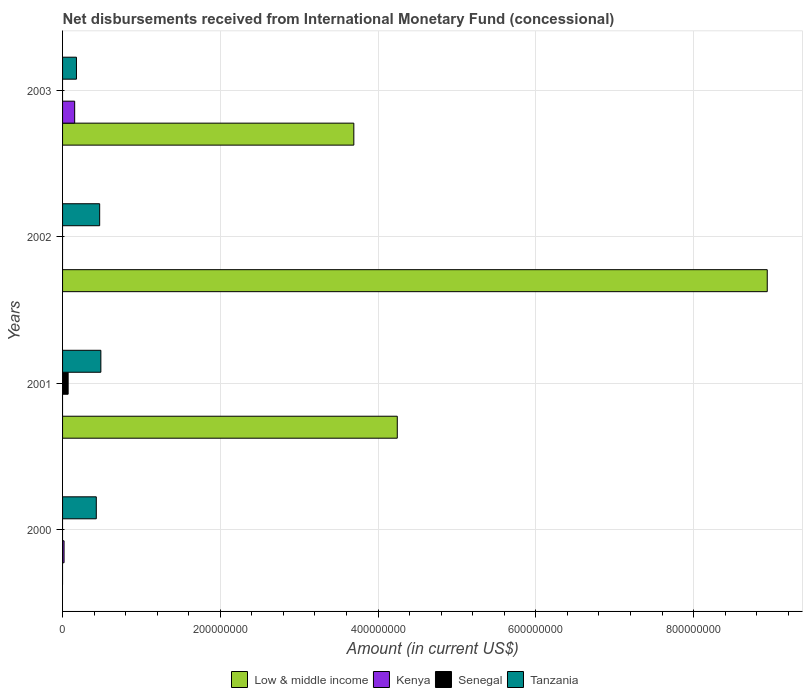How many different coloured bars are there?
Ensure brevity in your answer.  4. Are the number of bars per tick equal to the number of legend labels?
Give a very brief answer. No. How many bars are there on the 1st tick from the top?
Make the answer very short. 3. How many bars are there on the 1st tick from the bottom?
Provide a short and direct response. 2. What is the label of the 3rd group of bars from the top?
Keep it short and to the point. 2001. In how many cases, is the number of bars for a given year not equal to the number of legend labels?
Your answer should be compact. 4. Across all years, what is the maximum amount of disbursements received from International Monetary Fund in Senegal?
Your answer should be compact. 7.07e+06. What is the total amount of disbursements received from International Monetary Fund in Kenya in the graph?
Your answer should be very brief. 1.72e+07. What is the difference between the amount of disbursements received from International Monetary Fund in Tanzania in 2000 and that in 2003?
Provide a succinct answer. 2.52e+07. What is the difference between the amount of disbursements received from International Monetary Fund in Tanzania in 2000 and the amount of disbursements received from International Monetary Fund in Kenya in 2003?
Your answer should be compact. 2.74e+07. What is the average amount of disbursements received from International Monetary Fund in Kenya per year?
Your response must be concise. 4.31e+06. In the year 2001, what is the difference between the amount of disbursements received from International Monetary Fund in Tanzania and amount of disbursements received from International Monetary Fund in Low & middle income?
Make the answer very short. -3.76e+08. What is the ratio of the amount of disbursements received from International Monetary Fund in Tanzania in 2000 to that in 2002?
Your response must be concise. 0.91. What is the difference between the highest and the second highest amount of disbursements received from International Monetary Fund in Tanzania?
Your answer should be compact. 1.50e+06. What is the difference between the highest and the lowest amount of disbursements received from International Monetary Fund in Tanzania?
Keep it short and to the point. 3.10e+07. Is it the case that in every year, the sum of the amount of disbursements received from International Monetary Fund in Tanzania and amount of disbursements received from International Monetary Fund in Senegal is greater than the amount of disbursements received from International Monetary Fund in Low & middle income?
Keep it short and to the point. No. How many bars are there?
Your answer should be very brief. 10. Are all the bars in the graph horizontal?
Make the answer very short. Yes. How many years are there in the graph?
Ensure brevity in your answer.  4. What is the difference between two consecutive major ticks on the X-axis?
Offer a terse response. 2.00e+08. Are the values on the major ticks of X-axis written in scientific E-notation?
Keep it short and to the point. No. Does the graph contain any zero values?
Provide a succinct answer. Yes. Does the graph contain grids?
Your answer should be compact. Yes. Where does the legend appear in the graph?
Ensure brevity in your answer.  Bottom center. How many legend labels are there?
Provide a succinct answer. 4. How are the legend labels stacked?
Offer a very short reply. Horizontal. What is the title of the graph?
Your response must be concise. Net disbursements received from International Monetary Fund (concessional). Does "Belize" appear as one of the legend labels in the graph?
Your answer should be compact. No. What is the label or title of the X-axis?
Give a very brief answer. Amount (in current US$). What is the Amount (in current US$) of Kenya in 2000?
Keep it short and to the point. 1.90e+06. What is the Amount (in current US$) in Senegal in 2000?
Keep it short and to the point. 0. What is the Amount (in current US$) in Tanzania in 2000?
Your answer should be very brief. 4.28e+07. What is the Amount (in current US$) of Low & middle income in 2001?
Your answer should be compact. 4.24e+08. What is the Amount (in current US$) in Senegal in 2001?
Offer a terse response. 7.07e+06. What is the Amount (in current US$) of Tanzania in 2001?
Keep it short and to the point. 4.86e+07. What is the Amount (in current US$) of Low & middle income in 2002?
Offer a very short reply. 8.93e+08. What is the Amount (in current US$) in Tanzania in 2002?
Keep it short and to the point. 4.70e+07. What is the Amount (in current US$) of Low & middle income in 2003?
Ensure brevity in your answer.  3.69e+08. What is the Amount (in current US$) of Kenya in 2003?
Offer a very short reply. 1.53e+07. What is the Amount (in current US$) in Tanzania in 2003?
Ensure brevity in your answer.  1.76e+07. Across all years, what is the maximum Amount (in current US$) in Low & middle income?
Provide a short and direct response. 8.93e+08. Across all years, what is the maximum Amount (in current US$) in Kenya?
Your answer should be compact. 1.53e+07. Across all years, what is the maximum Amount (in current US$) in Senegal?
Provide a succinct answer. 7.07e+06. Across all years, what is the maximum Amount (in current US$) of Tanzania?
Your response must be concise. 4.86e+07. Across all years, what is the minimum Amount (in current US$) in Tanzania?
Keep it short and to the point. 1.76e+07. What is the total Amount (in current US$) of Low & middle income in the graph?
Make the answer very short. 1.69e+09. What is the total Amount (in current US$) of Kenya in the graph?
Ensure brevity in your answer.  1.72e+07. What is the total Amount (in current US$) in Senegal in the graph?
Make the answer very short. 7.07e+06. What is the total Amount (in current US$) of Tanzania in the graph?
Ensure brevity in your answer.  1.56e+08. What is the difference between the Amount (in current US$) of Tanzania in 2000 and that in 2001?
Ensure brevity in your answer.  -5.78e+06. What is the difference between the Amount (in current US$) of Tanzania in 2000 and that in 2002?
Provide a short and direct response. -4.28e+06. What is the difference between the Amount (in current US$) of Kenya in 2000 and that in 2003?
Offer a terse response. -1.34e+07. What is the difference between the Amount (in current US$) in Tanzania in 2000 and that in 2003?
Provide a short and direct response. 2.52e+07. What is the difference between the Amount (in current US$) of Low & middle income in 2001 and that in 2002?
Ensure brevity in your answer.  -4.69e+08. What is the difference between the Amount (in current US$) in Tanzania in 2001 and that in 2002?
Your answer should be compact. 1.50e+06. What is the difference between the Amount (in current US$) of Low & middle income in 2001 and that in 2003?
Your response must be concise. 5.51e+07. What is the difference between the Amount (in current US$) in Tanzania in 2001 and that in 2003?
Offer a very short reply. 3.10e+07. What is the difference between the Amount (in current US$) of Low & middle income in 2002 and that in 2003?
Provide a succinct answer. 5.24e+08. What is the difference between the Amount (in current US$) in Tanzania in 2002 and that in 2003?
Offer a very short reply. 2.95e+07. What is the difference between the Amount (in current US$) of Kenya in 2000 and the Amount (in current US$) of Senegal in 2001?
Make the answer very short. -5.17e+06. What is the difference between the Amount (in current US$) in Kenya in 2000 and the Amount (in current US$) in Tanzania in 2001?
Offer a very short reply. -4.67e+07. What is the difference between the Amount (in current US$) in Kenya in 2000 and the Amount (in current US$) in Tanzania in 2002?
Your answer should be compact. -4.52e+07. What is the difference between the Amount (in current US$) in Kenya in 2000 and the Amount (in current US$) in Tanzania in 2003?
Your answer should be compact. -1.57e+07. What is the difference between the Amount (in current US$) of Low & middle income in 2001 and the Amount (in current US$) of Tanzania in 2002?
Your answer should be compact. 3.77e+08. What is the difference between the Amount (in current US$) of Senegal in 2001 and the Amount (in current US$) of Tanzania in 2002?
Ensure brevity in your answer.  -4.00e+07. What is the difference between the Amount (in current US$) in Low & middle income in 2001 and the Amount (in current US$) in Kenya in 2003?
Give a very brief answer. 4.09e+08. What is the difference between the Amount (in current US$) of Low & middle income in 2001 and the Amount (in current US$) of Tanzania in 2003?
Your answer should be compact. 4.07e+08. What is the difference between the Amount (in current US$) in Senegal in 2001 and the Amount (in current US$) in Tanzania in 2003?
Give a very brief answer. -1.05e+07. What is the difference between the Amount (in current US$) in Low & middle income in 2002 and the Amount (in current US$) in Kenya in 2003?
Make the answer very short. 8.78e+08. What is the difference between the Amount (in current US$) in Low & middle income in 2002 and the Amount (in current US$) in Tanzania in 2003?
Keep it short and to the point. 8.76e+08. What is the average Amount (in current US$) of Low & middle income per year?
Offer a terse response. 4.22e+08. What is the average Amount (in current US$) in Kenya per year?
Your response must be concise. 4.31e+06. What is the average Amount (in current US$) in Senegal per year?
Make the answer very short. 1.77e+06. What is the average Amount (in current US$) in Tanzania per year?
Ensure brevity in your answer.  3.90e+07. In the year 2000, what is the difference between the Amount (in current US$) of Kenya and Amount (in current US$) of Tanzania?
Give a very brief answer. -4.09e+07. In the year 2001, what is the difference between the Amount (in current US$) of Low & middle income and Amount (in current US$) of Senegal?
Your answer should be compact. 4.17e+08. In the year 2001, what is the difference between the Amount (in current US$) in Low & middle income and Amount (in current US$) in Tanzania?
Offer a terse response. 3.76e+08. In the year 2001, what is the difference between the Amount (in current US$) in Senegal and Amount (in current US$) in Tanzania?
Keep it short and to the point. -4.15e+07. In the year 2002, what is the difference between the Amount (in current US$) of Low & middle income and Amount (in current US$) of Tanzania?
Your answer should be compact. 8.46e+08. In the year 2003, what is the difference between the Amount (in current US$) of Low & middle income and Amount (in current US$) of Kenya?
Offer a very short reply. 3.54e+08. In the year 2003, what is the difference between the Amount (in current US$) of Low & middle income and Amount (in current US$) of Tanzania?
Offer a very short reply. 3.52e+08. In the year 2003, what is the difference between the Amount (in current US$) in Kenya and Amount (in current US$) in Tanzania?
Keep it short and to the point. -2.25e+06. What is the ratio of the Amount (in current US$) in Tanzania in 2000 to that in 2001?
Give a very brief answer. 0.88. What is the ratio of the Amount (in current US$) of Tanzania in 2000 to that in 2002?
Provide a short and direct response. 0.91. What is the ratio of the Amount (in current US$) in Kenya in 2000 to that in 2003?
Keep it short and to the point. 0.12. What is the ratio of the Amount (in current US$) of Tanzania in 2000 to that in 2003?
Ensure brevity in your answer.  2.43. What is the ratio of the Amount (in current US$) in Low & middle income in 2001 to that in 2002?
Offer a terse response. 0.47. What is the ratio of the Amount (in current US$) of Tanzania in 2001 to that in 2002?
Provide a short and direct response. 1.03. What is the ratio of the Amount (in current US$) in Low & middle income in 2001 to that in 2003?
Ensure brevity in your answer.  1.15. What is the ratio of the Amount (in current US$) of Tanzania in 2001 to that in 2003?
Make the answer very short. 2.76. What is the ratio of the Amount (in current US$) in Low & middle income in 2002 to that in 2003?
Keep it short and to the point. 2.42. What is the ratio of the Amount (in current US$) of Tanzania in 2002 to that in 2003?
Make the answer very short. 2.67. What is the difference between the highest and the second highest Amount (in current US$) in Low & middle income?
Provide a succinct answer. 4.69e+08. What is the difference between the highest and the second highest Amount (in current US$) of Tanzania?
Provide a short and direct response. 1.50e+06. What is the difference between the highest and the lowest Amount (in current US$) of Low & middle income?
Provide a short and direct response. 8.93e+08. What is the difference between the highest and the lowest Amount (in current US$) in Kenya?
Ensure brevity in your answer.  1.53e+07. What is the difference between the highest and the lowest Amount (in current US$) of Senegal?
Ensure brevity in your answer.  7.07e+06. What is the difference between the highest and the lowest Amount (in current US$) in Tanzania?
Your response must be concise. 3.10e+07. 